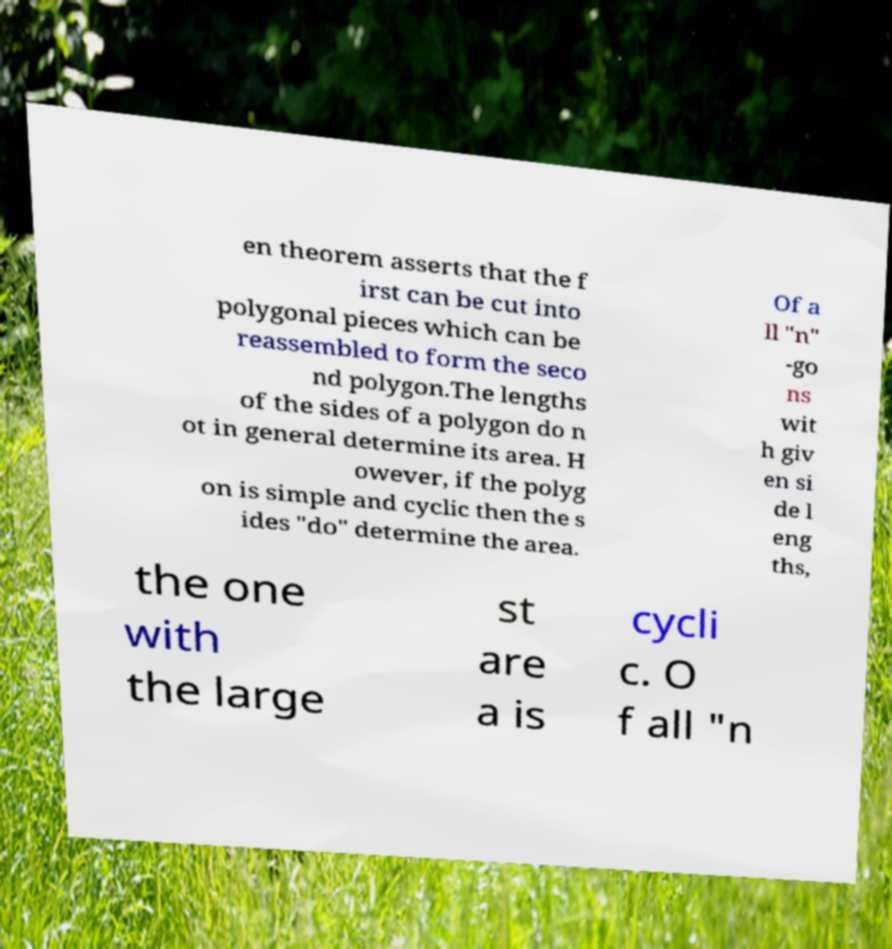What messages or text are displayed in this image? I need them in a readable, typed format. en theorem asserts that the f irst can be cut into polygonal pieces which can be reassembled to form the seco nd polygon.The lengths of the sides of a polygon do n ot in general determine its area. H owever, if the polyg on is simple and cyclic then the s ides "do" determine the area. Of a ll "n" -go ns wit h giv en si de l eng ths, the one with the large st are a is cycli c. O f all "n 